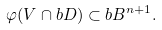<formula> <loc_0><loc_0><loc_500><loc_500>\varphi ( V \cap b D ) \subset b B ^ { n + 1 } .</formula> 